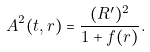Convert formula to latex. <formula><loc_0><loc_0><loc_500><loc_500>A ^ { 2 } ( t , r ) = \frac { ( R ^ { \prime } ) ^ { 2 } } { 1 + f ( r ) } .</formula> 